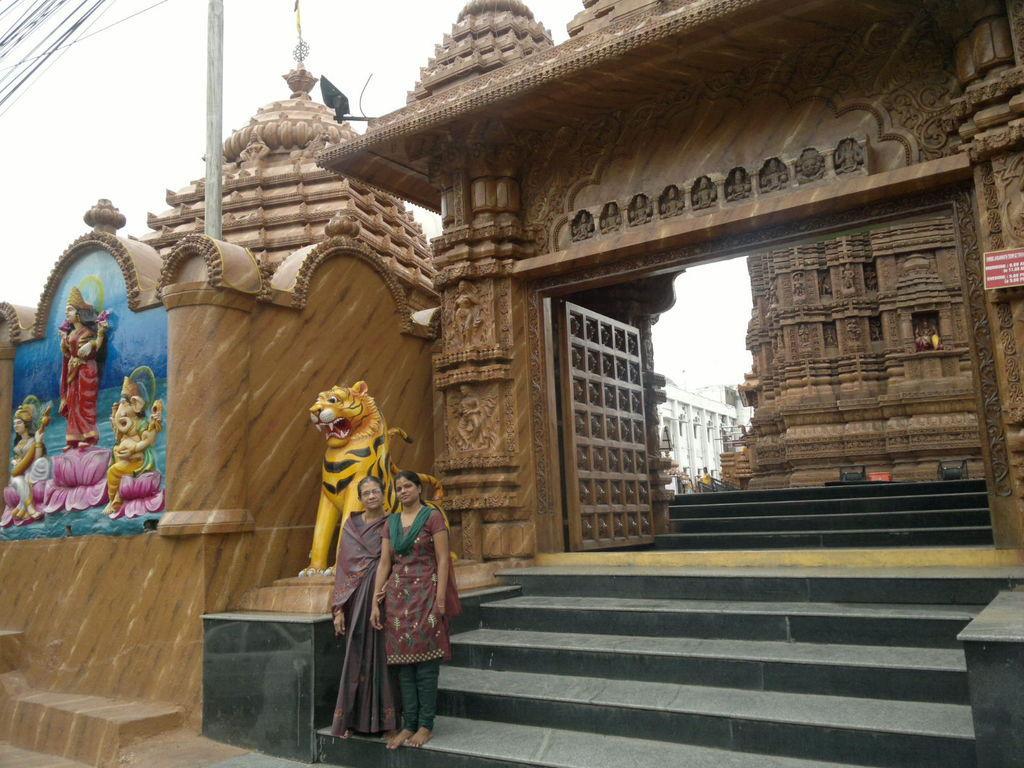In one or two sentences, can you explain what this image depicts? In the image, it is a temple and there are two people standing in front of a lion statue and posing for the photo at the entrance of the temple. 